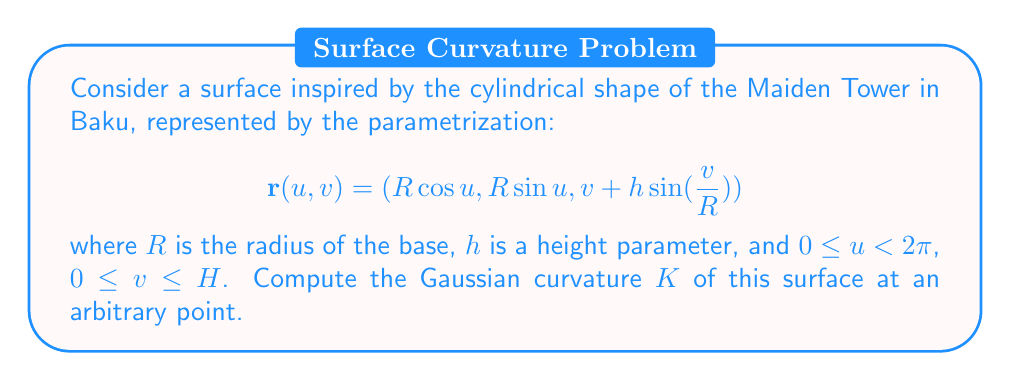Could you help me with this problem? To compute the Gaussian curvature, we'll follow these steps:

1) First, we need to calculate the partial derivatives:
   $$\mathbf{r}_u = (-R\sin u, R\cos u, 0)$$
   $$\mathbf{r}_v = (0, 0, 1 + \frac{h}{R}\cos(\frac{v}{R}))$$

2) Next, we calculate the second partial derivatives:
   $$\mathbf{r}_{uu} = (-R\cos u, -R\sin u, 0)$$
   $$\mathbf{r}_{uv} = (0, 0, 0)$$
   $$\mathbf{r}_{vv} = (0, 0, -\frac{h}{R^2}\sin(\frac{v}{R}))$$

3) Now we can compute the coefficients of the first fundamental form:
   $$E = \mathbf{r}_u \cdot \mathbf{r}_u = R^2$$
   $$F = \mathbf{r}_u \cdot \mathbf{r}_v = 0$$
   $$G = \mathbf{r}_v \cdot \mathbf{r}_v = (1 + \frac{h}{R}\cos(\frac{v}{R}))^2$$

4) And the coefficients of the second fundamental form:
   $$\mathbf{n} = \frac{\mathbf{r}_u \times \mathbf{r}_v}{|\mathbf{r}_u \times \mathbf{r}_v|} = (\cos u, \sin u, -\frac{h}{R}\cos(\frac{v}{R}))$$
   $$L = \mathbf{r}_{uu} \cdot \mathbf{n} = -R$$
   $$M = \mathbf{r}_{uv} \cdot \mathbf{n} = 0$$
   $$N = \mathbf{r}_{vv} \cdot \mathbf{n} = -\frac{h}{R^2}\sin(\frac{v}{R})$$

5) The Gaussian curvature is given by:
   $$K = \frac{LN - M^2}{EG - F^2}$$

6) Substituting the values:
   $$K = \frac{(-R)(-\frac{h}{R^2}\sin(\frac{v}{R})) - 0^2}{R^2(1 + \frac{h}{R}\cos(\frac{v}{R}))^2 - 0^2}$$

7) Simplifying:
   $$K = \frac{\frac{h}{R^3}\sin(\frac{v}{R})}{(1 + \frac{h}{R}\cos(\frac{v}{R}))^2}$$
Answer: $$K = \frac{\frac{h}{R^3}\sin(\frac{v}{R})}{(1 + \frac{h}{R}\cos(\frac{v}{R}))^2}$$ 